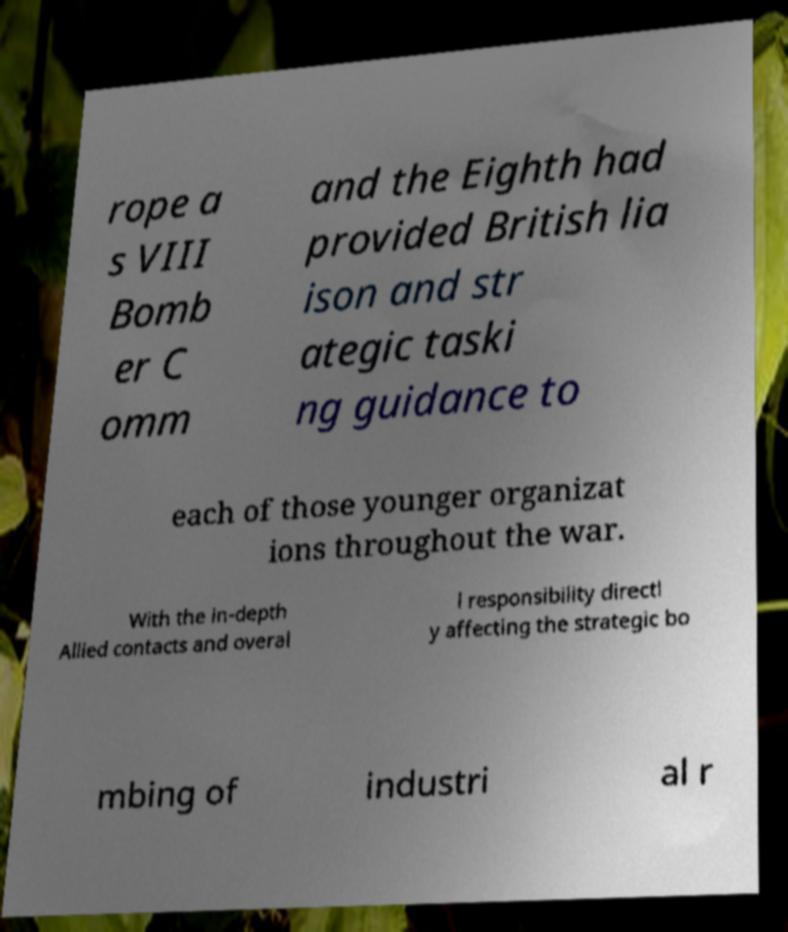Can you accurately transcribe the text from the provided image for me? rope a s VIII Bomb er C omm and the Eighth had provided British lia ison and str ategic taski ng guidance to each of those younger organizat ions throughout the war. With the in-depth Allied contacts and overal l responsibility directl y affecting the strategic bo mbing of industri al r 